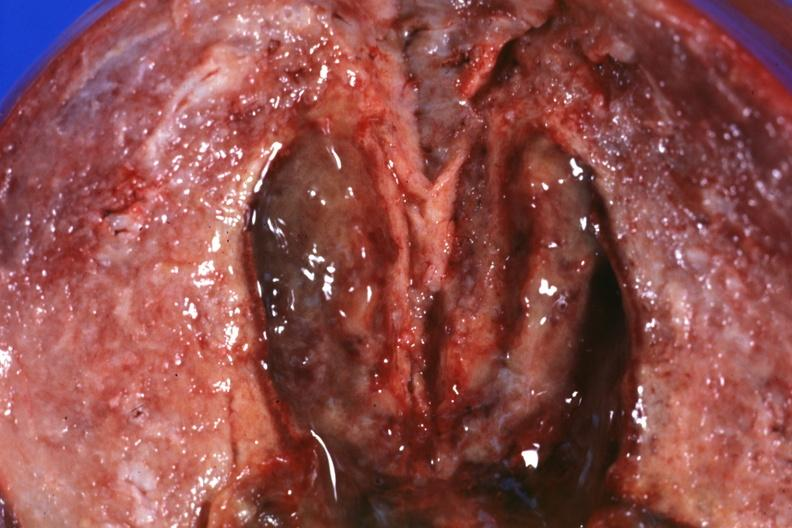s cortical nodule present?
Answer the question using a single word or phrase. No 